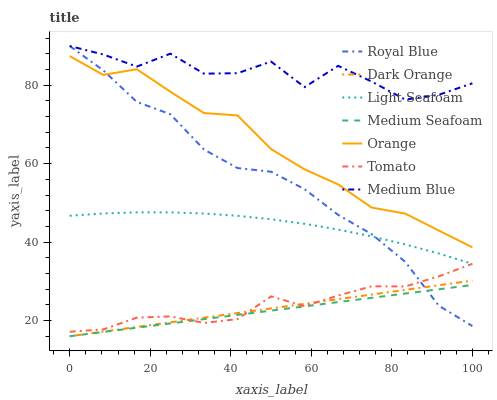Does Medium Seafoam have the minimum area under the curve?
Answer yes or no. Yes. Does Medium Blue have the maximum area under the curve?
Answer yes or no. Yes. Does Dark Orange have the minimum area under the curve?
Answer yes or no. No. Does Dark Orange have the maximum area under the curve?
Answer yes or no. No. Is Dark Orange the smoothest?
Answer yes or no. Yes. Is Medium Blue the roughest?
Answer yes or no. Yes. Is Medium Blue the smoothest?
Answer yes or no. No. Is Dark Orange the roughest?
Answer yes or no. No. Does Dark Orange have the lowest value?
Answer yes or no. Yes. Does Medium Blue have the lowest value?
Answer yes or no. No. Does Royal Blue have the highest value?
Answer yes or no. Yes. Does Dark Orange have the highest value?
Answer yes or no. No. Is Orange less than Medium Blue?
Answer yes or no. Yes. Is Orange greater than Tomato?
Answer yes or no. Yes. Does Royal Blue intersect Medium Seafoam?
Answer yes or no. Yes. Is Royal Blue less than Medium Seafoam?
Answer yes or no. No. Is Royal Blue greater than Medium Seafoam?
Answer yes or no. No. Does Orange intersect Medium Blue?
Answer yes or no. No. 